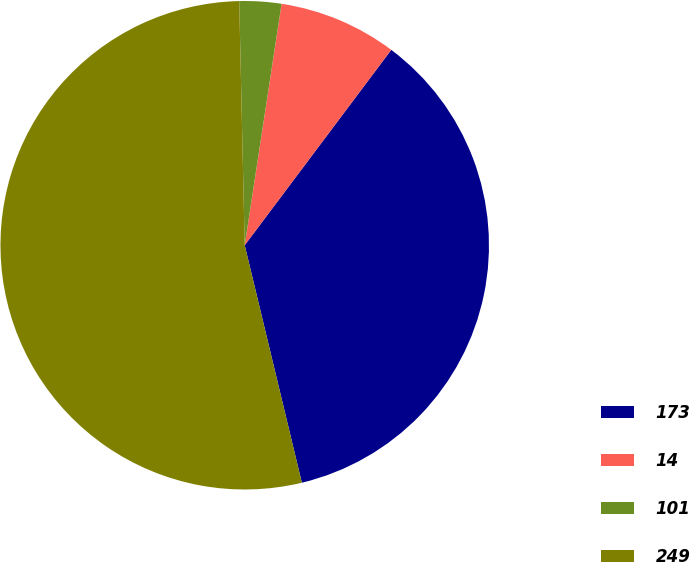Convert chart to OTSL. <chart><loc_0><loc_0><loc_500><loc_500><pie_chart><fcel>173<fcel>14<fcel>101<fcel>249<nl><fcel>36.0%<fcel>7.83%<fcel>2.77%<fcel>53.4%<nl></chart> 